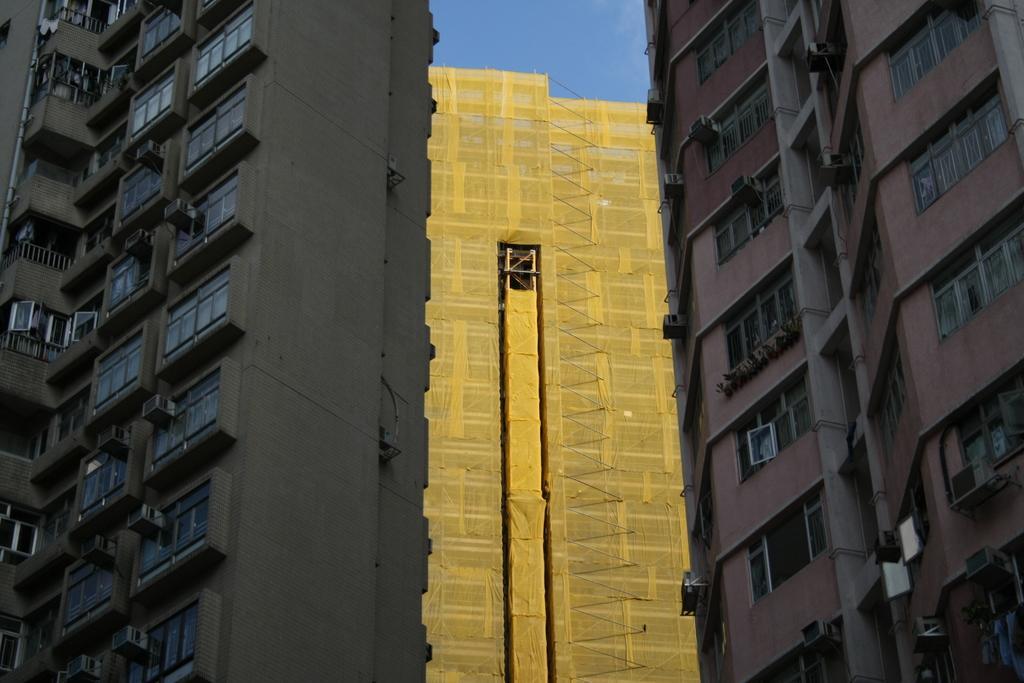In one or two sentences, can you explain what this image depicts? In this image there are few buildings, windows and the sky. 